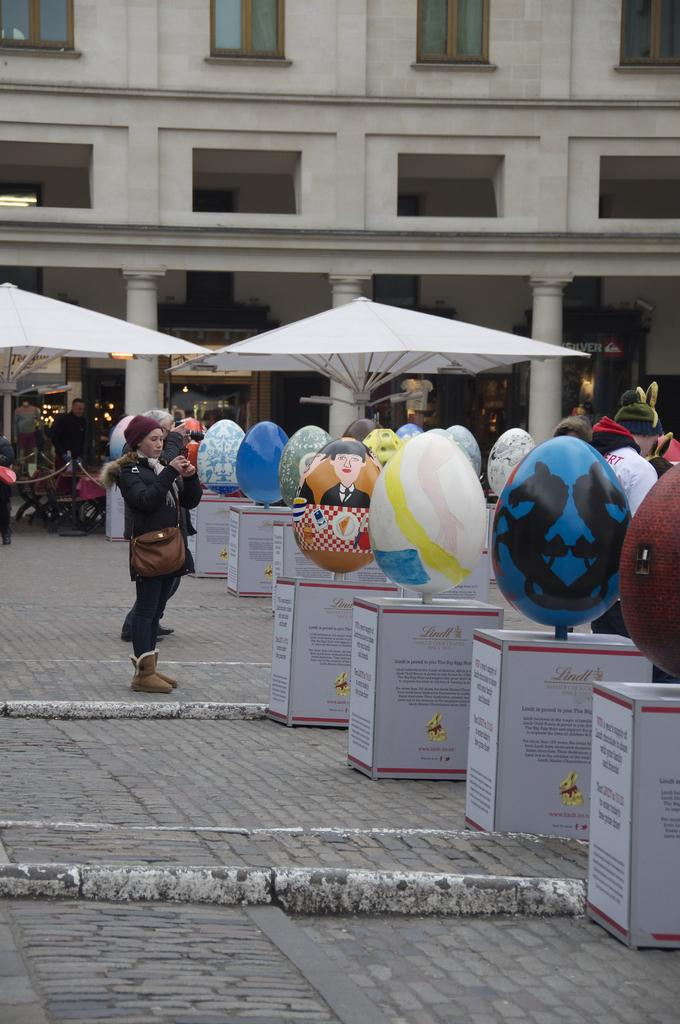What can be seen in the image that is used for holding balloons? There are balloon stands in the image. What is the general atmosphere in the image? There is a crowd in the image, suggesting a busy or eventful scene. What type of shelter is available for people in the image? There are umbrella huts in the image for people to take shelter. What can be seen in the background of the image? There is a building in the background of the image, and windows are visible. When was the image taken? The image was taken during the day. What hour of the day is the development being offered in the image? There is no mention of a development or an offer in the image; it features balloon stands, a crowd, umbrella huts, a building, windows, and was taken during the day. 